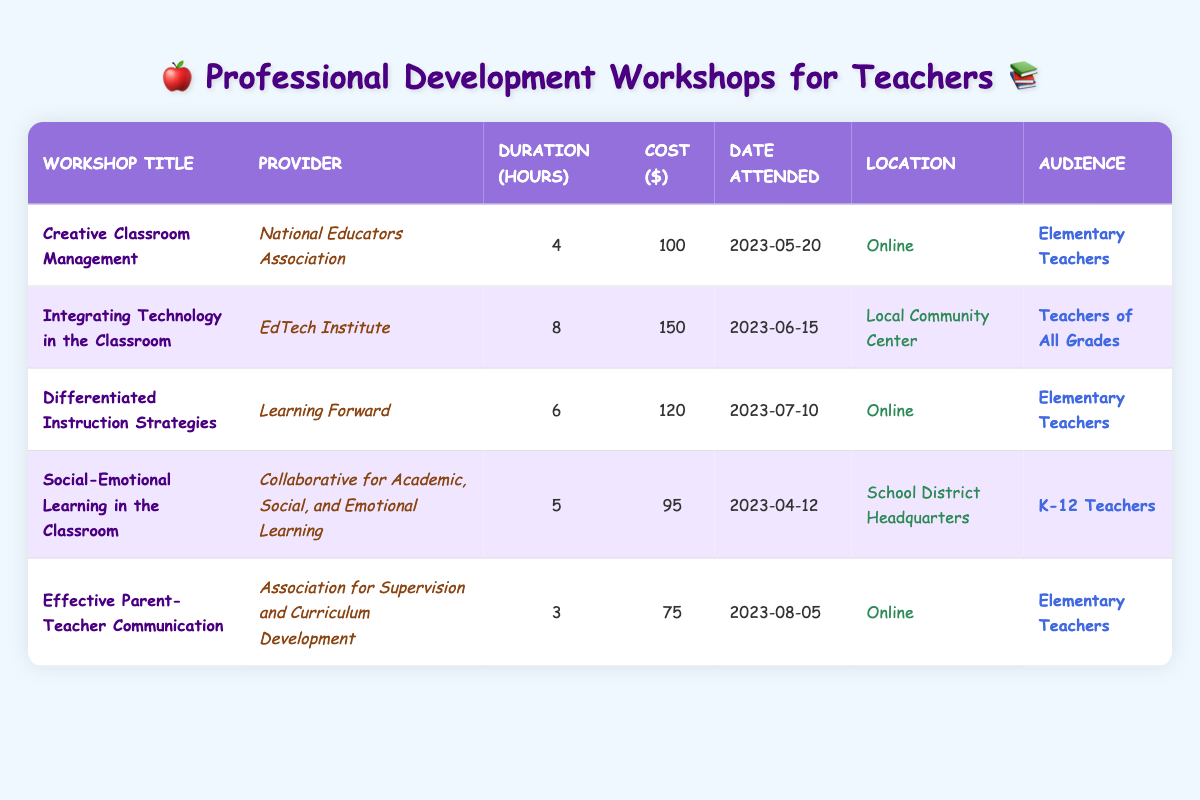What is the title of the workshop provided by the National Educators Association? The workshop provided by the National Educators Association is listed under the "Workshop Title" column in the table. According to the table, the title is "Creative Classroom Management."
Answer: Creative Classroom Management How many hours was the workshop "Integrating Technology in the Classroom"? The duration of the workshop is found in the "Duration (hours)" column next to the corresponding workshop title. For "Integrating Technology in the Classroom," the duration is 8 hours.
Answer: 8 What was the total cost of attending all the workshops? To find the total cost, add up the costs for each workshop. The costs are: 100 + 150 + 120 + 95 + 75 = 640. Thus, the total cost is 640 dollars.
Answer: 640 Did all workshops include the audience "Elementary Teachers"? By reviewing the "Audience" column, we can check how many workshops are marked for "Elementary Teachers." The workshops that target "Elementary Teachers" are: "Creative Classroom Management," "Differentiated Instruction Strategies," and "Effective Parent-Teacher Communication." Therefore, not all workshops included "Elementary Teachers."
Answer: No Which workshop had the longest duration and what was the provider? To determine the longest duration, we check the "Duration (hours)" column for the highest number. The longest duration is 8 hours, and it corresponds to the workshop "Integrating Technology in the Classroom," provided by the "EdTech Institute."
Answer: Integrating Technology in the Classroom; EdTech Institute How much did the shortest workshop cost and where was it held? The shortest workshop can be identified by looking for the lowest number in the "Duration (hours)" column. The shortest one is "Effective Parent-Teacher Communication," which lasted 3 hours and cost 75 dollars. According to the "Location" column, it was held online.
Answer: 75 dollars; Online What is the average cost of the workshops attended? To calculate the average cost, first add up all the costs: 100 + 150 + 120 + 95 + 75 = 640. Then, divide this total by the number of workshops, which is 5: 640/5 = 128. Therefore, the average cost of the workshops attended is 128 dollars.
Answer: 128 Is the workshop "Social-Emotional Learning in the Classroom" only catered to K-12 teachers? Checking the "Audience" column, the workshop "Social-Emotional Learning in the Classroom" is indeed specified for K-12 Teachers, and it does not cater to other groups.
Answer: Yes Which provider offered a workshop for "Teachers of All Grades"? The "Audience" column helps identify workshops by their target groups. The "Integrating Technology in the Classroom" workshop is the only one listed for "Teachers of All Grades," which is provided by the "EdTech Institute."
Answer: EdTech Institute 